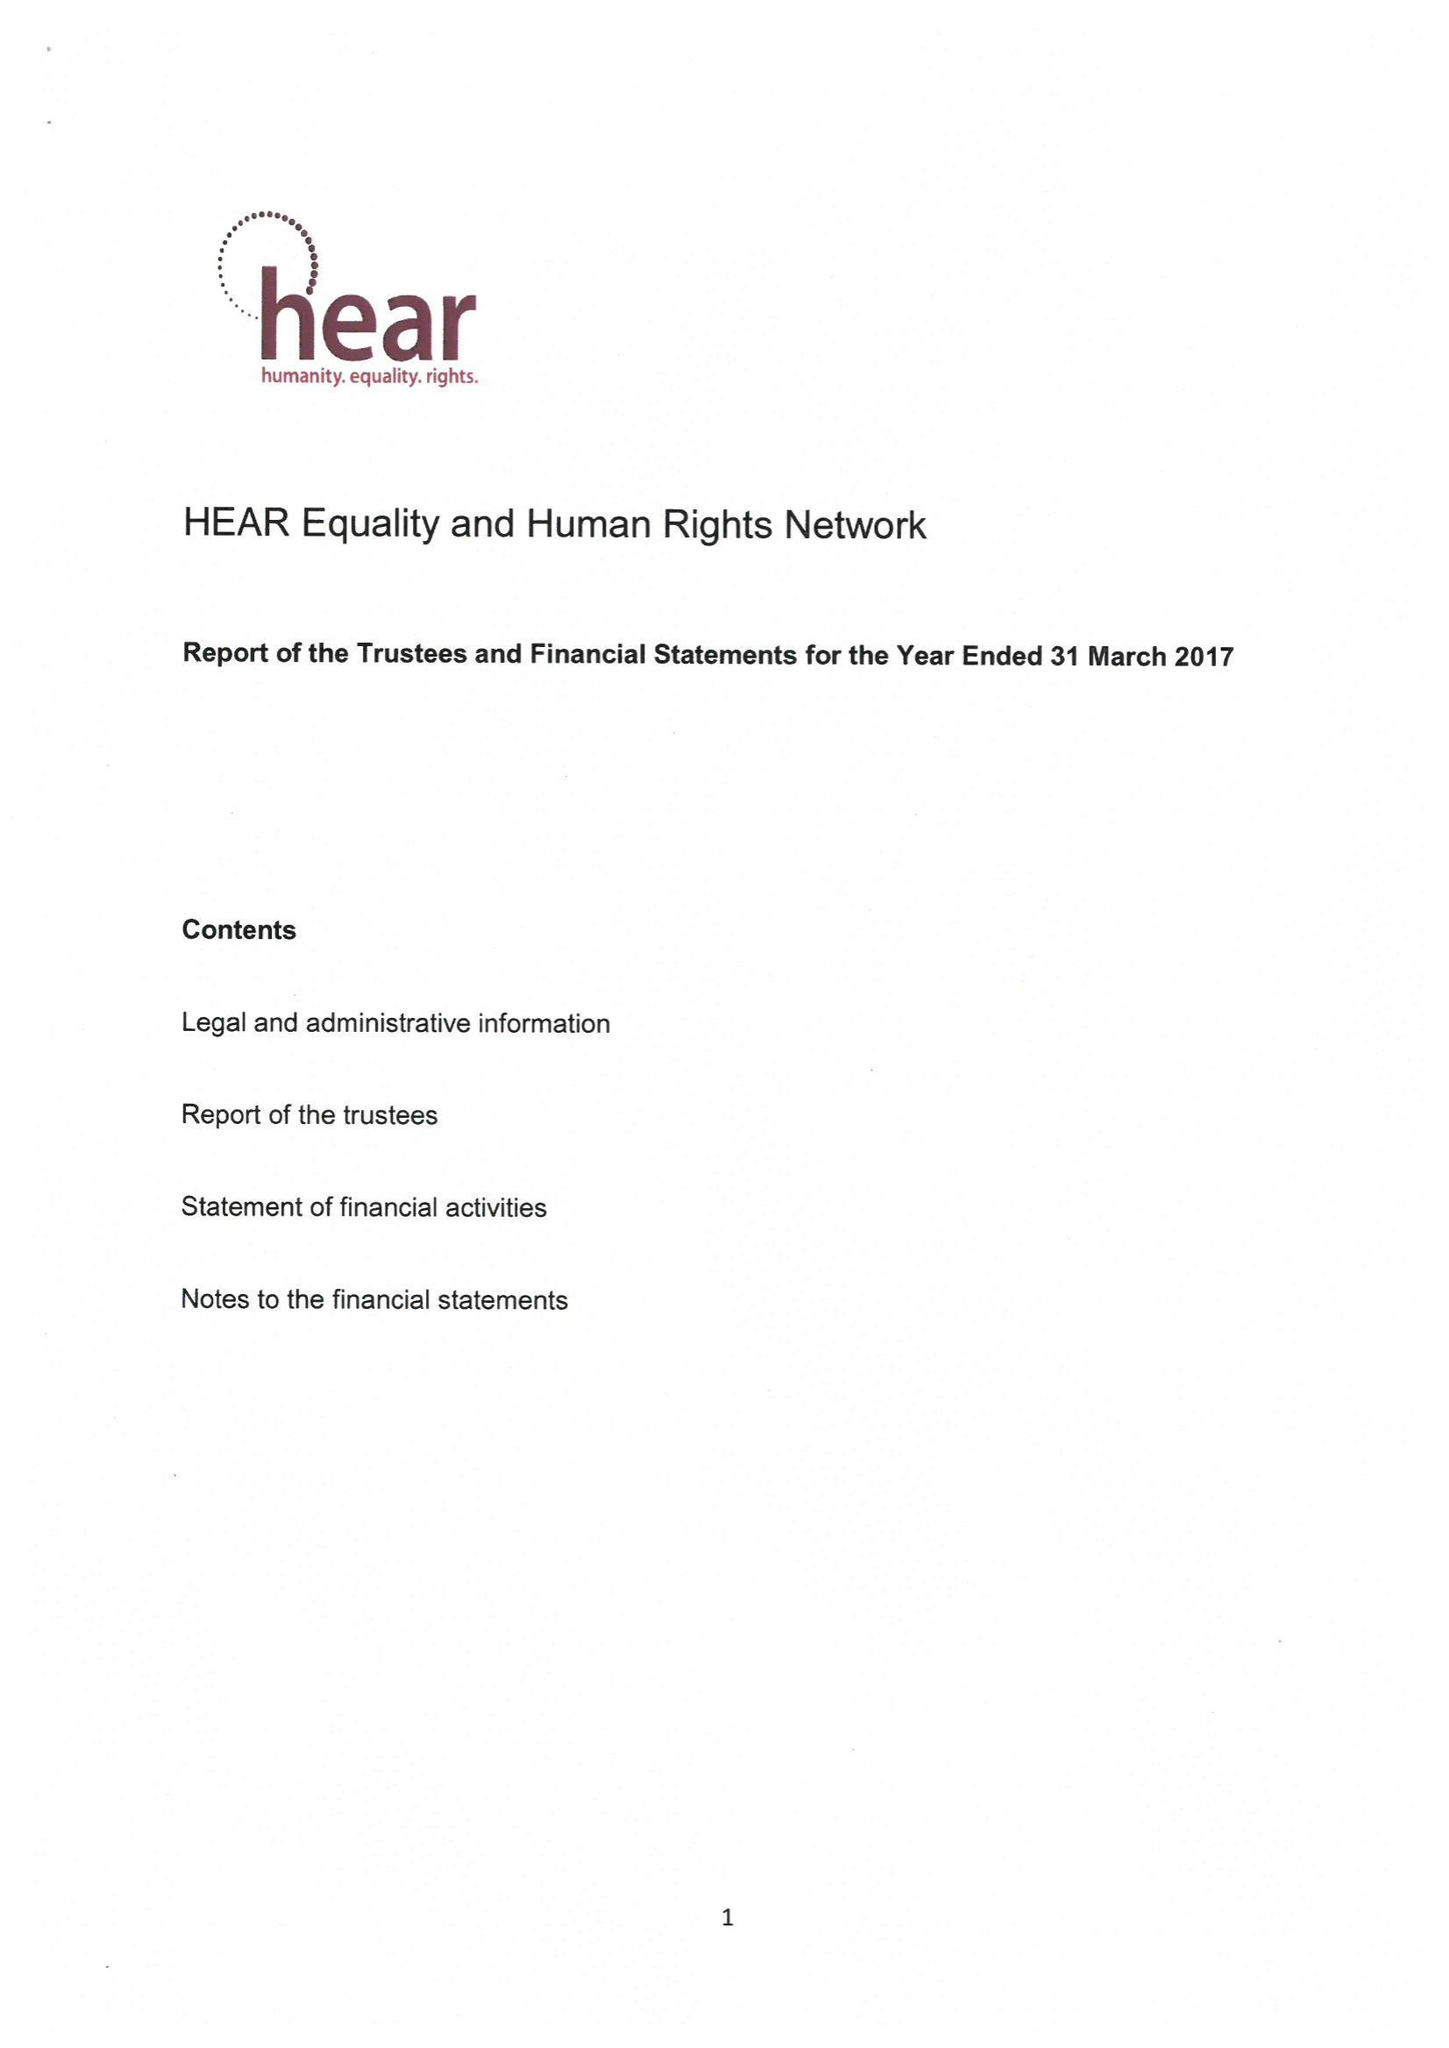What is the value for the address__post_town?
Answer the question using a single word or phrase. LONDON 